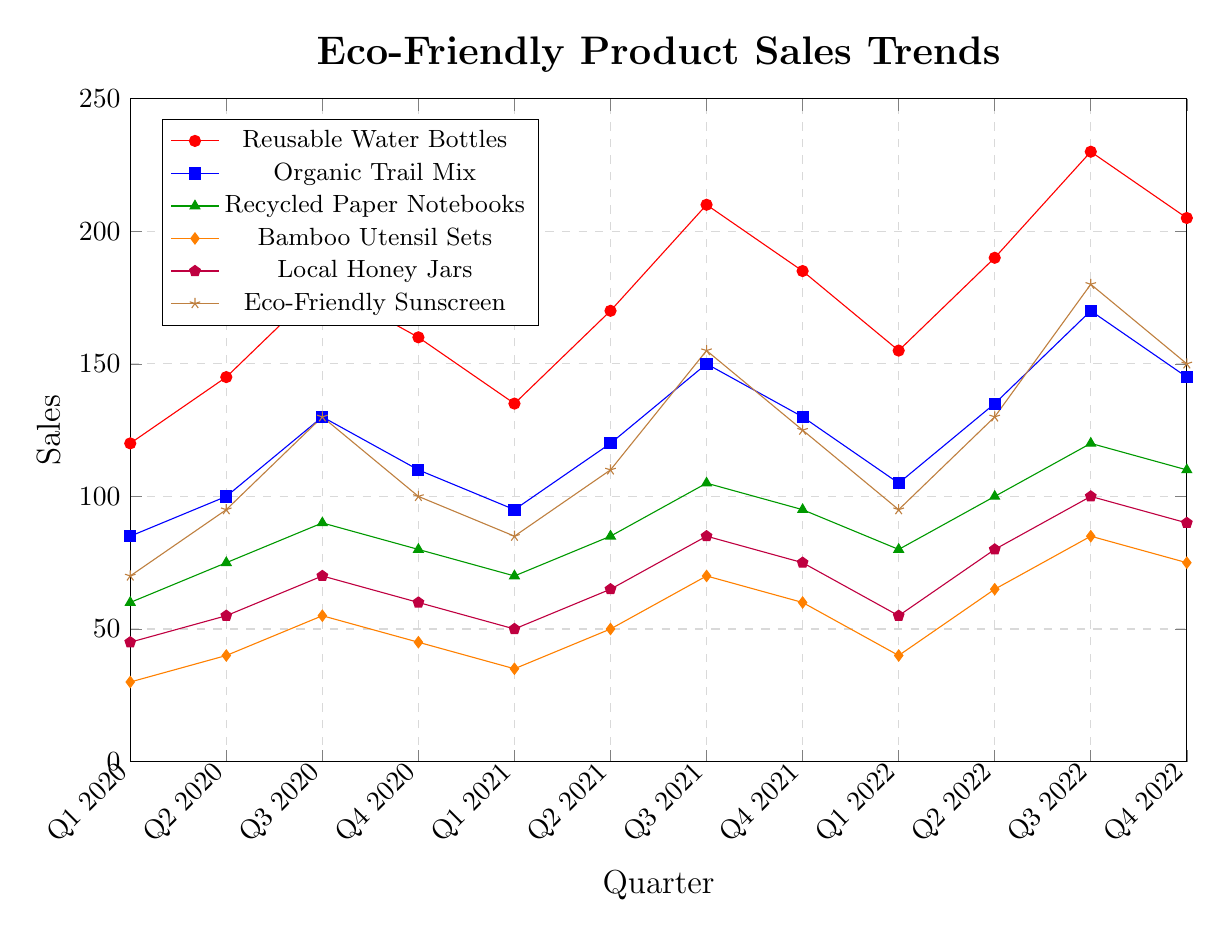What is the highest sales figure observed for any product? Looking at the plot, the highest sales figure can be found at the peak of one of the lines. The highest peak is for the Reusable Water Bottles in Q3 2022 with 230 units.
Answer: 230 Which product had the lowest sales in Q1 2020? Observing the sales figures for each product in Q1 2020, Bamboo Utensil Sets had the lowest sales with 30 units.
Answer: Bamboo Utensil Sets Between Q4 2020 and Q1 2021, which product saw the greatest decrease in sales? Calculate the differences in sales between Q4 2020 and Q1 2021 for each product. The greatest decrease was for Reusable Water Bottles, from 160 to 135, a decrease of 25 units.
Answer: Reusable Water Bottles By how much did sales for Eco-Friendly Sunscreen change from Q1 2020 to Q3 2020? In Q1 2020, Eco-Friendly Sunscreens sold 70 units. By Q3 2020, sales increased to 130 units. The change is 130 - 70 = 60 units.
Answer: 60 Which product had the steadiest increase in sales over the three years? Comparing the sales trends for all products, Reusable Water Bottles show a consistent increase over the period with minor fluctuations.
Answer: Reusable Water Bottles How do sales of Local Honey Jars in Q2 2020 compare to those in Q2 2022? In Q2 2020, Local Honey Jars sold 55 units. By Q2 2022, sales increased to 80 units, a comparison showing a difference of 25 units.
Answer: 25 What is the average quarterly sales figure for Organic Trail Mix in 2021? Adding sales for each quarter of 2021: 95 + 120 + 150 + 130 = 495. Dividing by 4 quarters, the average sales figure is 495 / 4 = 123.75.
Answer: 123.75 Between which two consecutive quarters did Reusable Water Bottles see the sharpest sales increase? Identify changes between consecutive quarters for Reusable Water Bottles. The sharpest increase was from Q2 2022 to Q3 2022, where sales rose from 190 to 230, a change of 40.
Answer: Q2 2022 to Q3 2022 What was the trend of Bamboo Utensil Sets sale from Q1 2020 to Q4 2021? Examining the Bamboo Utensil Sets sales line from Q1 2020 to Q4 2021, they started from 30 units, increased to 70 by Q3 2021, and then slightly dipped to 60 by Q4 2021.
Answer: Increasing Which product's sales are represented by the purple line in the plot? Observing the plot and its legend, the purple line corresponds to the sales of Local Honey Jars.
Answer: Local Honey Jars 